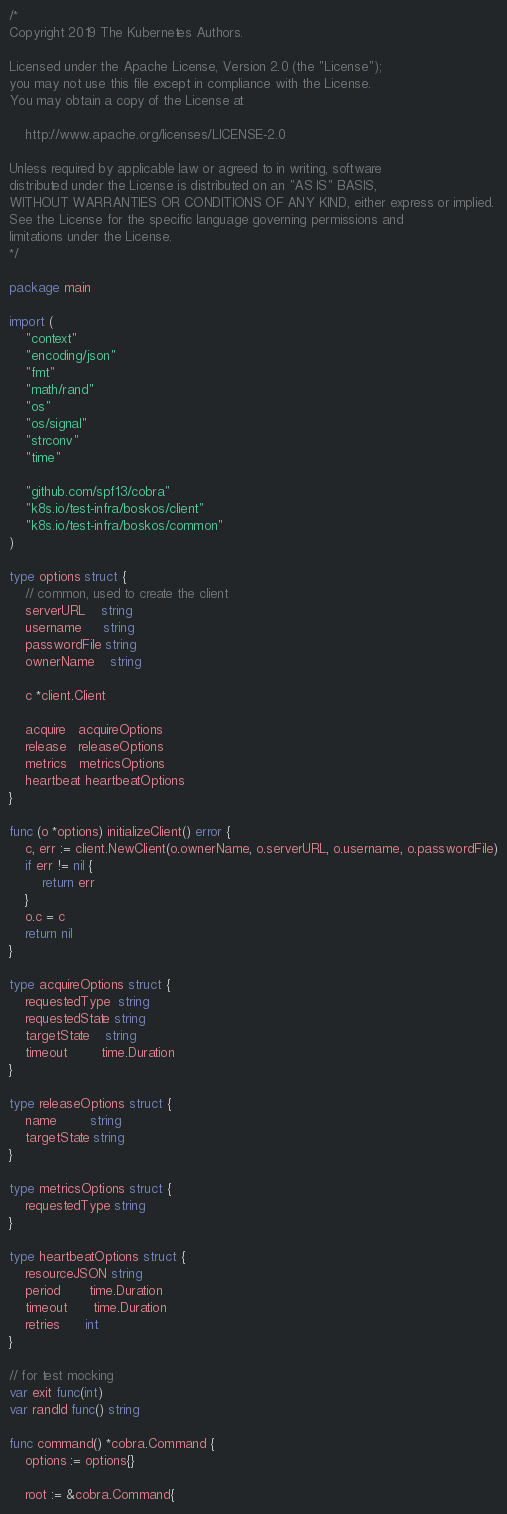Convert code to text. <code><loc_0><loc_0><loc_500><loc_500><_Go_>/*
Copyright 2019 The Kubernetes Authors.

Licensed under the Apache License, Version 2.0 (the "License");
you may not use this file except in compliance with the License.
You may obtain a copy of the License at

    http://www.apache.org/licenses/LICENSE-2.0

Unless required by applicable law or agreed to in writing, software
distributed under the License is distributed on an "AS IS" BASIS,
WITHOUT WARRANTIES OR CONDITIONS OF ANY KIND, either express or implied.
See the License for the specific language governing permissions and
limitations under the License.
*/

package main

import (
	"context"
	"encoding/json"
	"fmt"
	"math/rand"
	"os"
	"os/signal"
	"strconv"
	"time"

	"github.com/spf13/cobra"
	"k8s.io/test-infra/boskos/client"
	"k8s.io/test-infra/boskos/common"
)

type options struct {
	// common, used to create the client
	serverURL    string
	username     string
	passwordFile string
	ownerName    string

	c *client.Client

	acquire   acquireOptions
	release   releaseOptions
	metrics   metricsOptions
	heartbeat heartbeatOptions
}

func (o *options) initializeClient() error {
	c, err := client.NewClient(o.ownerName, o.serverURL, o.username, o.passwordFile)
	if err != nil {
		return err
	}
	o.c = c
	return nil
}

type acquireOptions struct {
	requestedType  string
	requestedState string
	targetState    string
	timeout        time.Duration
}

type releaseOptions struct {
	name        string
	targetState string
}

type metricsOptions struct {
	requestedType string
}

type heartbeatOptions struct {
	resourceJSON string
	period       time.Duration
	timeout      time.Duration
	retries      int
}

// for test mocking
var exit func(int)
var randId func() string

func command() *cobra.Command {
	options := options{}

	root := &cobra.Command{</code> 